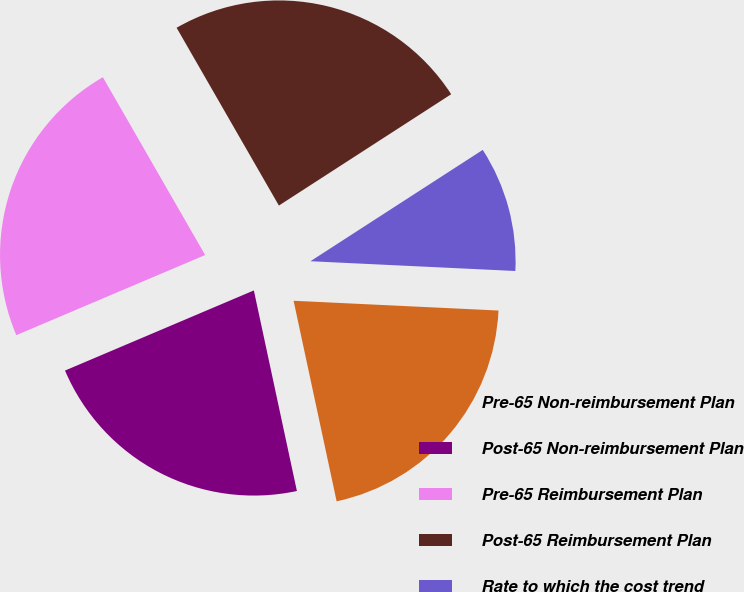Convert chart. <chart><loc_0><loc_0><loc_500><loc_500><pie_chart><fcel>Pre-65 Non-reimbursement Plan<fcel>Post-65 Non-reimbursement Plan<fcel>Pre-65 Reimbursement Plan<fcel>Post-65 Reimbursement Plan<fcel>Rate to which the cost trend<nl><fcel>20.88%<fcel>21.98%<fcel>23.08%<fcel>24.18%<fcel>9.89%<nl></chart> 